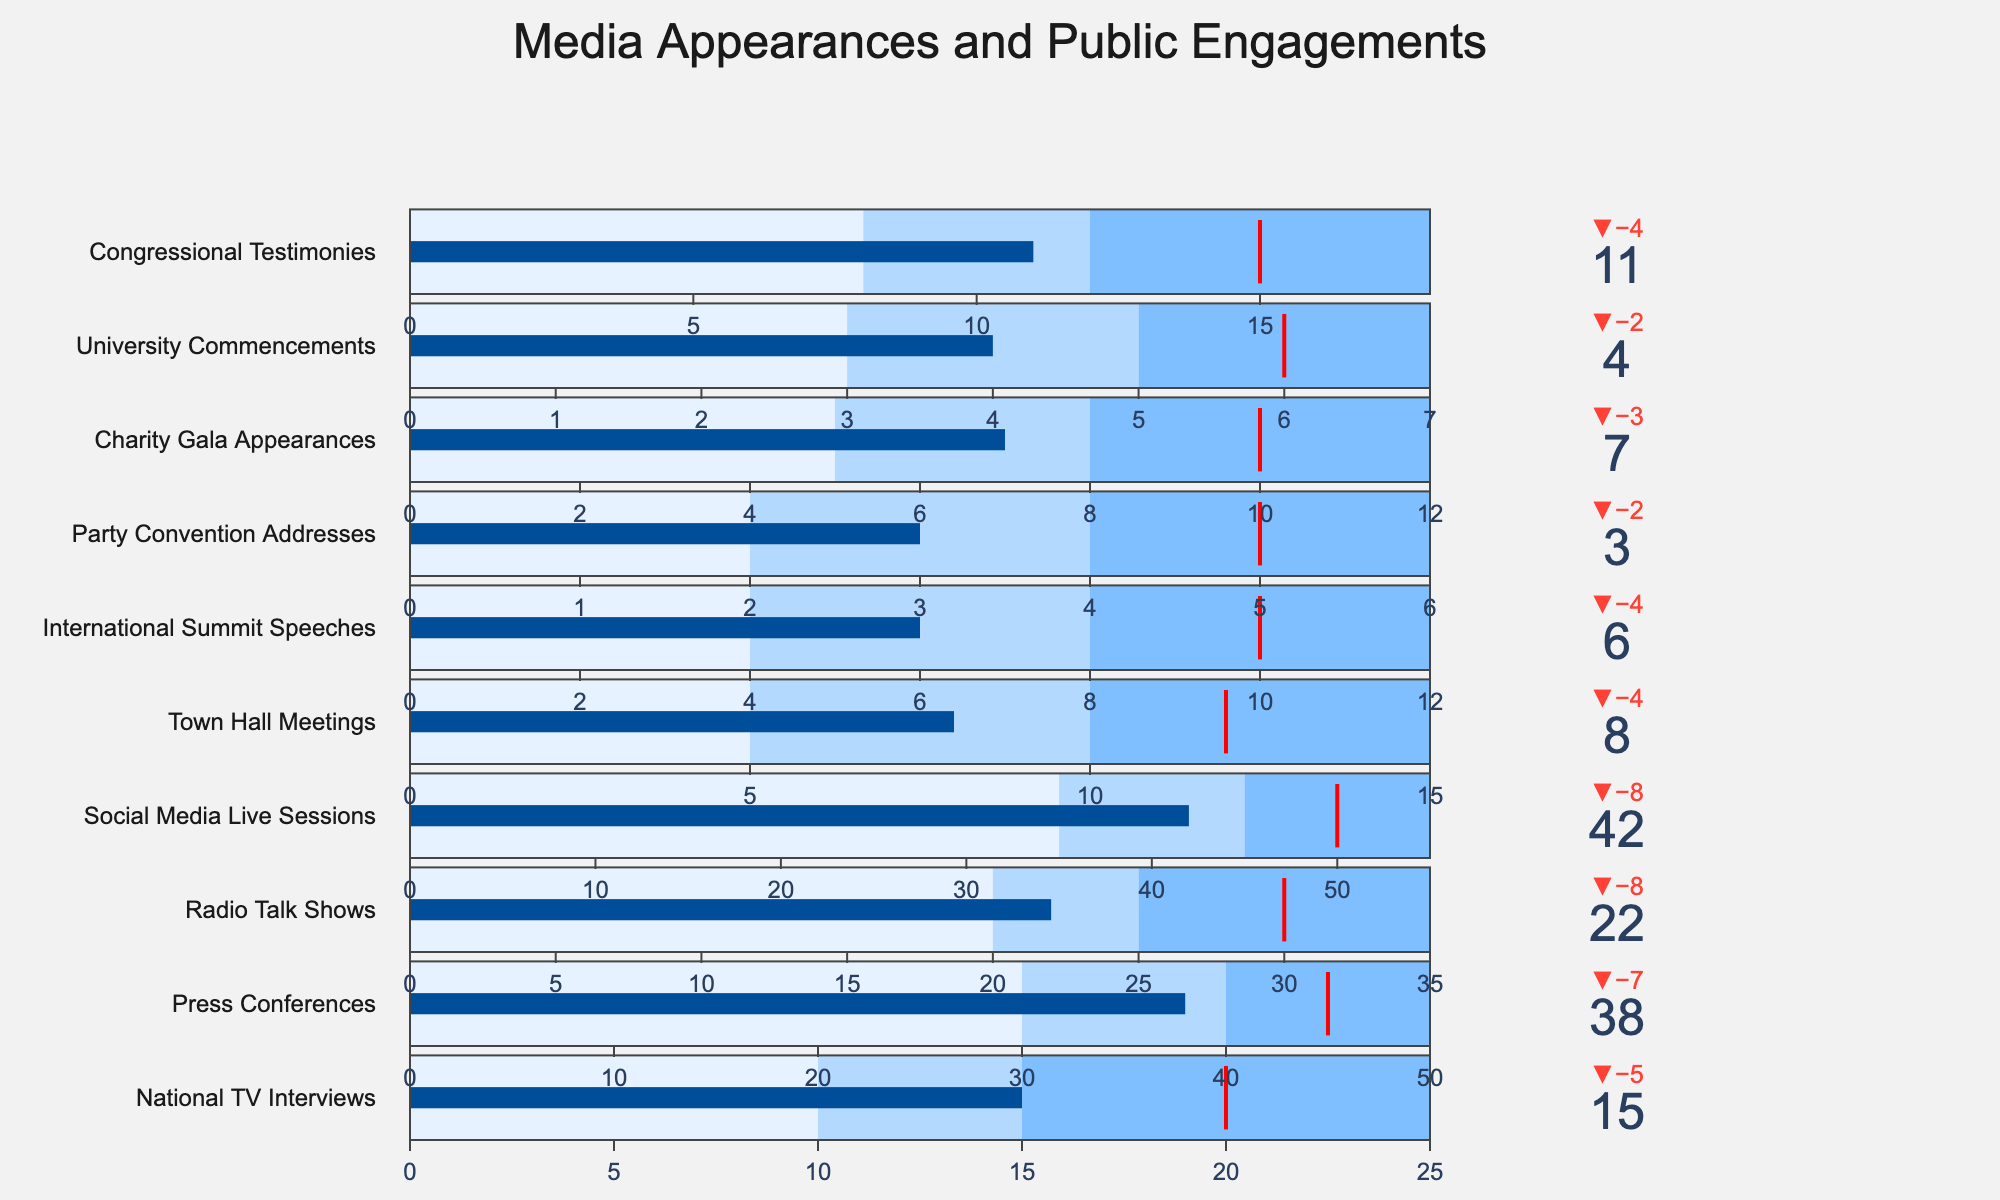What's the title of the chart? The title is displayed at the top of the chart. The large text at the top reads "Media Appearances and Public Engagements."
Answer: Media Appearances and Public Engagements Which category has the highest actual value? By looking at the bullet charts, the category with the highest actual value (indicated by the dark blue bar) is "Social Media Live Sessions" with an actual value of 42.
Answer: Social Media Live Sessions How many categories did not meet their target value? To count the categories that did not meet their target, compare the actual value with the target value for each category. The categories where the actual value is less than the target value are: National TV Interviews, Press Conferences, Radio Talk Shows, Town Hall Meetings, International Summit Speeches, Party Convention Addresses, Charity Gala Appearances, University Commencements, and Congressional Testimonies. This results in a total of 9 categories.
Answer: 9 What is the difference between the actual and target value for Press Conferences? To find the difference, subtract the actual value (38) from the target value (45) for Press Conferences. 45 - 38 = 7.
Answer: 7 Which category is closest to its target value? To determine which category is closest to its target value, calculate the absolute difference between the actual value and the target value for each category. The category with the smallest absolute difference is "International Summit Speeches," which has an actual value of 6 and a target value of 10 resulting in a difference of 4.
Answer: International Summit Speeches How many public engagements were made in total across all categories? To find the total number of public engagements, sum up the actual values across all categories: 15 (National TV Interviews) + 38 (Press Conferences) + 22 (Radio Talk Shows) + 42 (Social Media Live Sessions) + 8 (Town Hall Meetings) + 6 (International Summit Speeches) + 3 (Party Convention Addresses) + 7 (Charity Gala Appearances) + 4 (University Commencements) + 11 (Congressional Testimonies) = 156.
Answer: 156 Which category has the lowest actual value? By looking at the bullet charts, the category with the lowest actual value (indicated by the dark blue bar) is "Party Convention Addresses" with an actual value of 3.
Answer: Party Convention Addresses What proportion of the target was achieved for Town Hall Meetings? To determine the proportion, divide the actual value (8) by the target value (12) for Town Hall Meetings and multiply by 100 to convert to a percentage: (8/12) * 100 = ~66.67%.
Answer: ~66.67% How many categories surpassed their target value? To count the categories that surpassed their target, compare the actual value with the target value for each category. The category where the actual value is greater than the target value is "Social Media Live Sessions." Therefore, only 1 category met this condition.
Answer: 1 